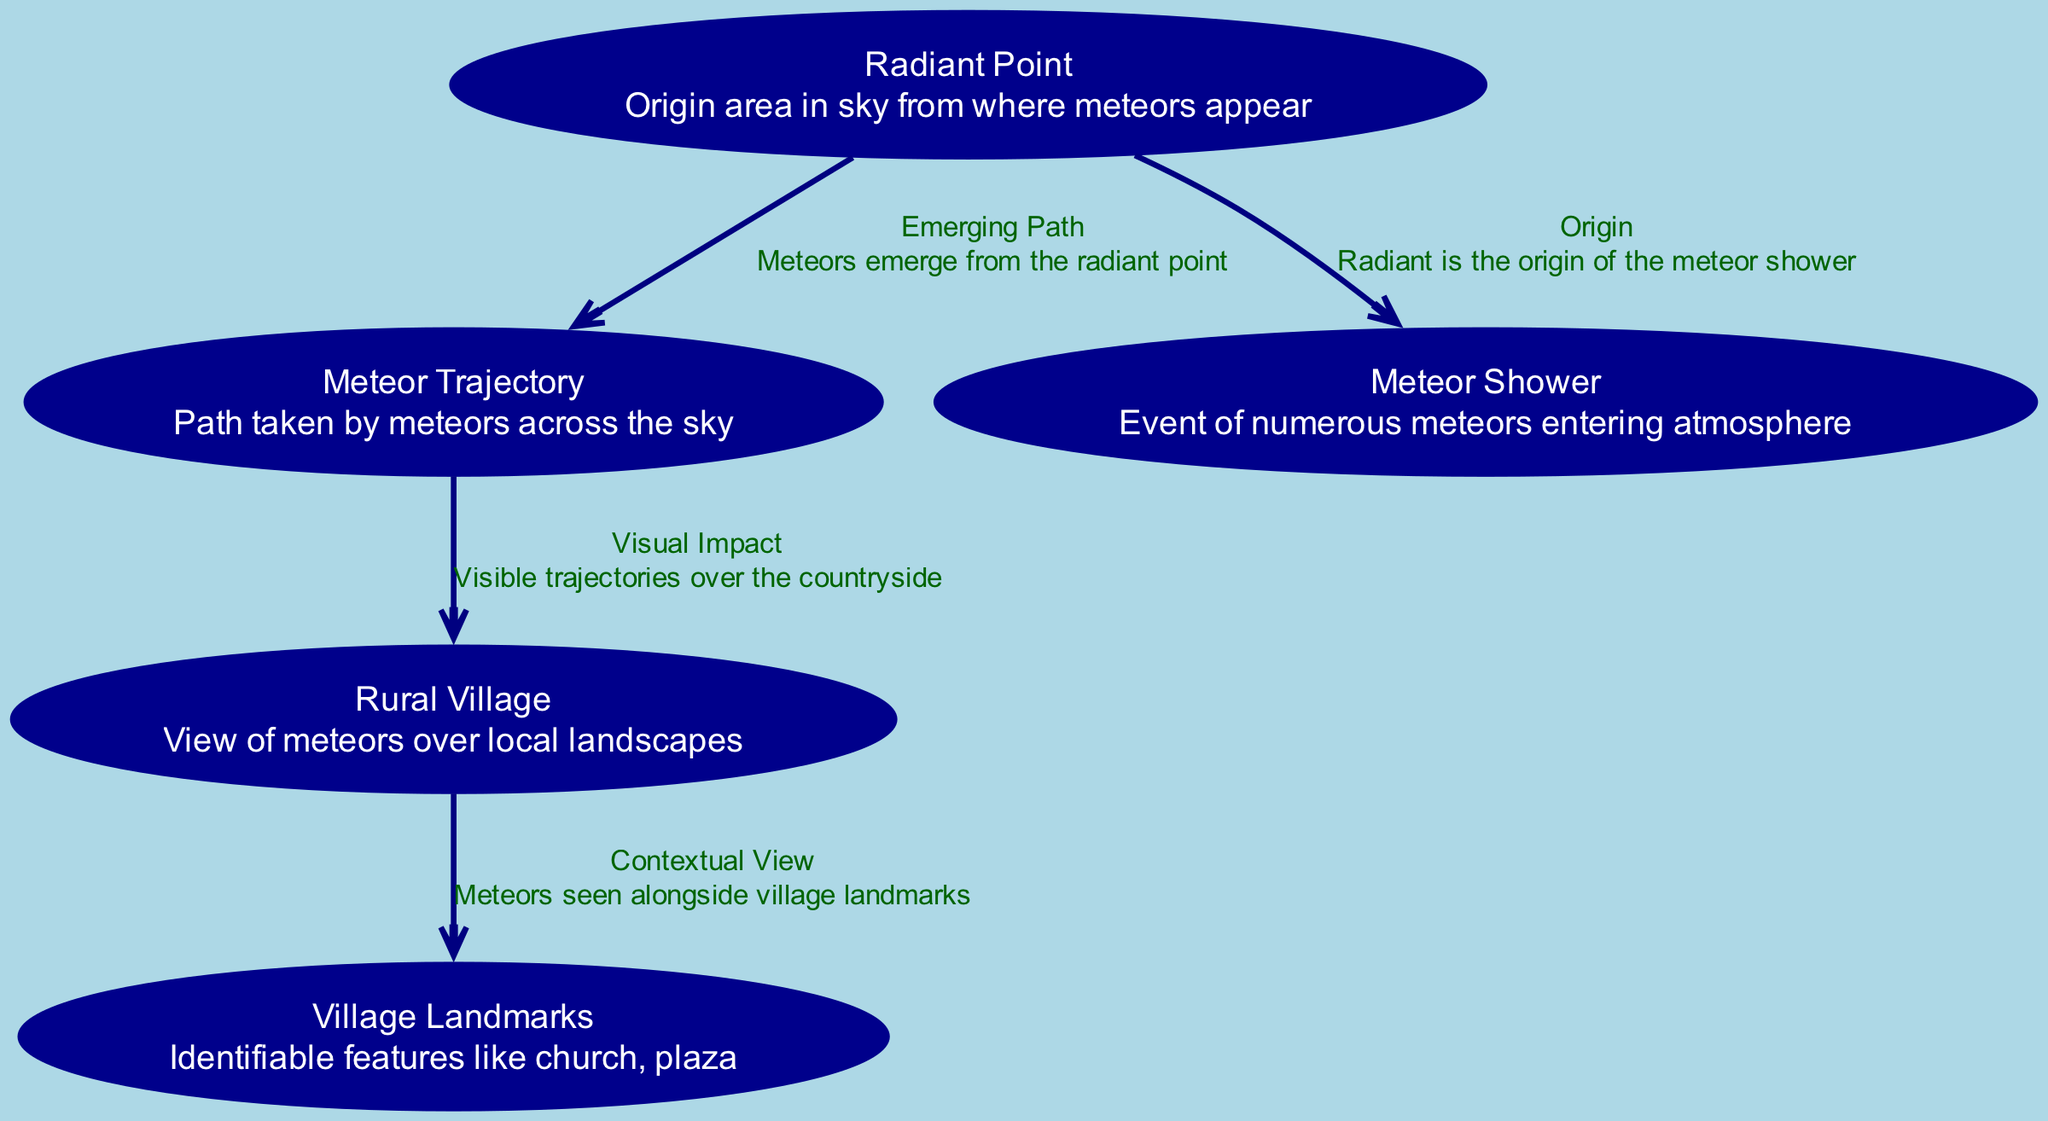What is the label of the node that represents the origin of meteors? The diagram includes a node labeled "Radiant Point" which indicates the area in the sky from where meteors appear.
Answer: Radiant Point How many nodes are present in the diagram? The diagram consists of five nodes: Radiant Point, Meteor Trajectory, Rural Village, Village Landmarks, and Meteor Shower.
Answer: 5 What relationship does the "Radiant Point" have with the "Meteor Shower"? The "Radiant Point" is connected to "Meteor Shower" with the label "Origin," indicating that the radiant is the origin of the meteor shower.
Answer: Origin Which node describes the visible paths of meteors in the sky? The node labeled "Meteor Trajectory" describes the path taken by meteors across the sky, indicating their visible paths.
Answer: Meteor Trajectory What is the visual impact of the meteors according to the diagram? The relationship labeled "Visual Impact" between "Meteor Trajectory" and "Rural Village" shows that the trajectories are visible over the countryside, illustrating their impact on the rural landscape.
Answer: Visible trajectories over countryside Why are village landmarks relevant in viewing meteor showers? The "Village Landmarks" node connects to "Rural Village" through "Contextual View," indicating that meteors are seen alongside identifiable features like the church and plaza, making them relevant in the viewing experience.
Answer: Contextual View What occurs at the edges that connect "Radiant Point" to "Meteor Shower"? The edge labeled "Origin" represents that the radiant point is the origin of the meteor shower, indicating where the event begins in the sky.
Answer: Origin What are the identifiable features mentioned in the diagram? The diagram mentions "Village Landmarks," which include recognizable features such as the church and plaza that aid in context during meteor showers.
Answer: Village Landmarks 